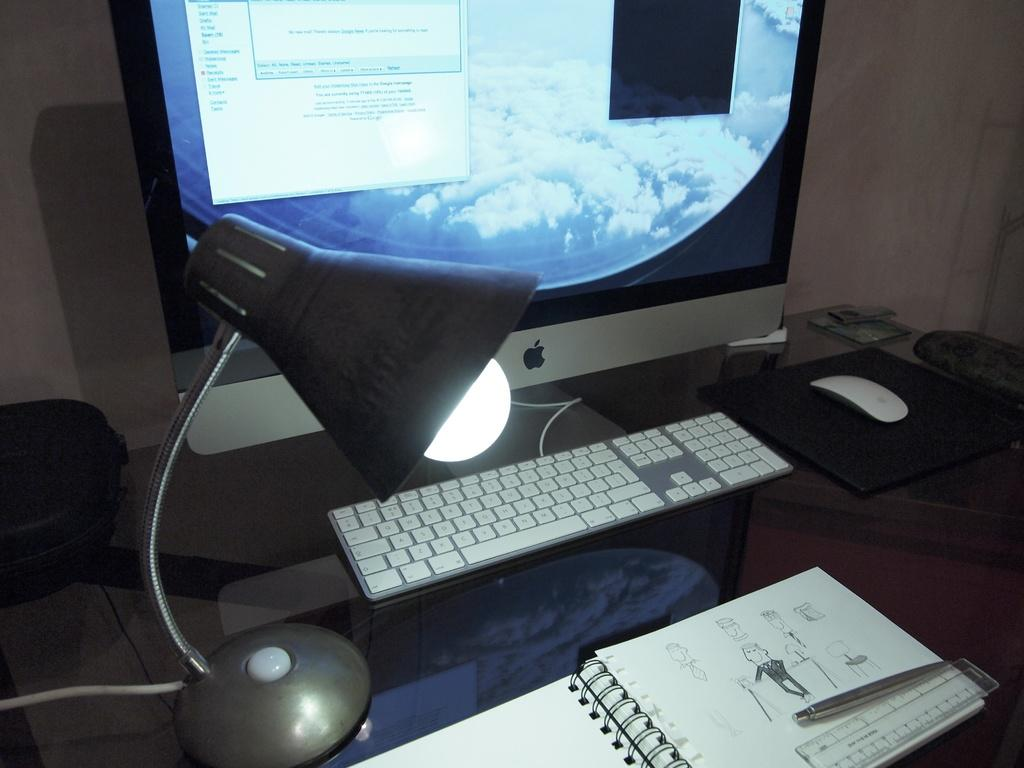<image>
Give a short and clear explanation of the subsequent image. An apple computer screen with a program that says no new mail. 